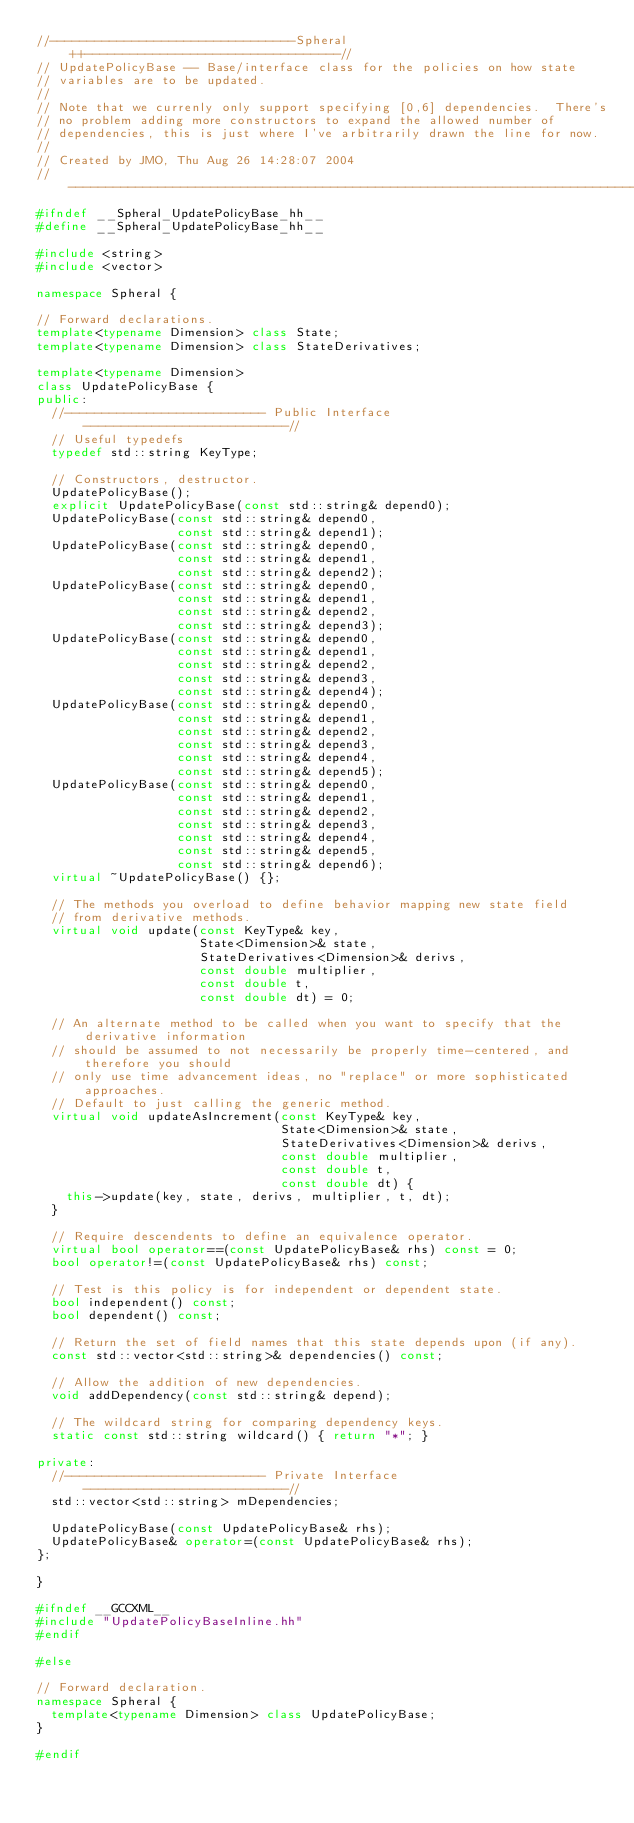Convert code to text. <code><loc_0><loc_0><loc_500><loc_500><_C++_>//---------------------------------Spheral++----------------------------------//
// UpdatePolicyBase -- Base/interface class for the policies on how state 
// variables are to be updated.
//
// Note that we currenly only support specifying [0,6] dependencies.  There's 
// no problem adding more constructors to expand the allowed number of 
// dependencies, this is just where I've arbitrarily drawn the line for now.
//
// Created by JMO, Thu Aug 26 14:28:07 2004
//----------------------------------------------------------------------------//
#ifndef __Spheral_UpdatePolicyBase_hh__
#define __Spheral_UpdatePolicyBase_hh__

#include <string>
#include <vector>

namespace Spheral {

// Forward declarations.
template<typename Dimension> class State;
template<typename Dimension> class StateDerivatives;

template<typename Dimension>
class UpdatePolicyBase {
public:
  //--------------------------- Public Interface ---------------------------//
  // Useful typedefs
  typedef std::string KeyType;

  // Constructors, destructor.
  UpdatePolicyBase();
  explicit UpdatePolicyBase(const std::string& depend0);
  UpdatePolicyBase(const std::string& depend0, 
                   const std::string& depend1);
  UpdatePolicyBase(const std::string& depend0, 
                   const std::string& depend1,
                   const std::string& depend2);
  UpdatePolicyBase(const std::string& depend0, 
                   const std::string& depend1, 
                   const std::string& depend2, 
                   const std::string& depend3);
  UpdatePolicyBase(const std::string& depend0, 
                   const std::string& depend1,
                   const std::string& depend2,
                   const std::string& depend3, 
                   const std::string& depend4);
  UpdatePolicyBase(const std::string& depend0, 
                   const std::string& depend1,
                   const std::string& depend2,
                   const std::string& depend3,
                   const std::string& depend4, 
                   const std::string& depend5);
  UpdatePolicyBase(const std::string& depend0,
                   const std::string& depend1,
                   const std::string& depend2, 
                   const std::string& depend3, 
                   const std::string& depend4,
                   const std::string& depend5,
                   const std::string& depend6);
  virtual ~UpdatePolicyBase() {};
  
  // The methods you overload to define behavior mapping new state field 
  // from derivative methods.
  virtual void update(const KeyType& key,
                      State<Dimension>& state,
                      StateDerivatives<Dimension>& derivs,
                      const double multiplier,
                      const double t,
                      const double dt) = 0;

  // An alternate method to be called when you want to specify that the derivative information
  // should be assumed to not necessarily be properly time-centered, and therefore you should 
  // only use time advancement ideas, no "replace" or more sophisticated approaches.
  // Default to just calling the generic method.
  virtual void updateAsIncrement(const KeyType& key,
                                 State<Dimension>& state,
                                 StateDerivatives<Dimension>& derivs,
                                 const double multiplier,
                                 const double t,
                                 const double dt) {
    this->update(key, state, derivs, multiplier, t, dt);
  }

  // Require descendents to define an equivalence operator.
  virtual bool operator==(const UpdatePolicyBase& rhs) const = 0;
  bool operator!=(const UpdatePolicyBase& rhs) const;

  // Test is this policy is for independent or dependent state.
  bool independent() const;
  bool dependent() const;

  // Return the set of field names that this state depends upon (if any).
  const std::vector<std::string>& dependencies() const;

  // Allow the addition of new dependencies.
  void addDependency(const std::string& depend);

  // The wildcard string for comparing dependency keys.
  static const std::string wildcard() { return "*"; }

private:
  //--------------------------- Private Interface ---------------------------//
  std::vector<std::string> mDependencies;

  UpdatePolicyBase(const UpdatePolicyBase& rhs);
  UpdatePolicyBase& operator=(const UpdatePolicyBase& rhs);
};

}

#ifndef __GCCXML__
#include "UpdatePolicyBaseInline.hh"
#endif

#else

// Forward declaration.
namespace Spheral {
  template<typename Dimension> class UpdatePolicyBase;
}

#endif
</code> 